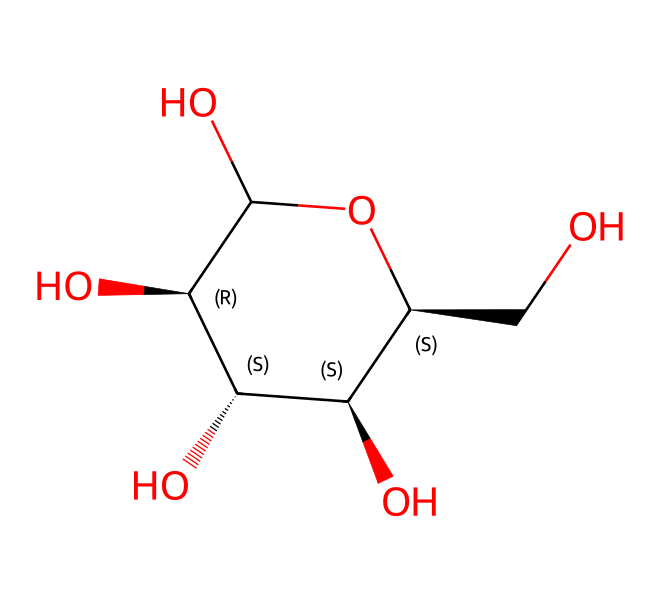What is the name of this chemical? The SMILES representation indicates that this compound is glucose, a common simple sugar.
Answer: glucose How many carbon atoms are in the structure? The SMILES shows that there are six carbon atoms present in glucose.
Answer: six What type of compound is glucose classified as? Glucose is classified as a non-electrolyte because it does not dissociate into ions in solution.
Answer: non-electrolyte How many hydroxyl (-OH) groups are present? By analyzing the structure, we can count five hydroxyl groups in glucose.
Answer: five Does this chemical have any chiral centers? Yes, glucose contains four chiral centers as indicated by the stereochemistry in the structure.
Answer: four Why is glucose important for warehouse workers? Glucose is a quick source of energy, which is essential for sustaining physical activity during warehouse tasks.
Answer: energy source What is the molecular formula of glucose? From the structure, we can derive that the molecular formula of glucose is C6H12O6.
Answer: C6H12O6 